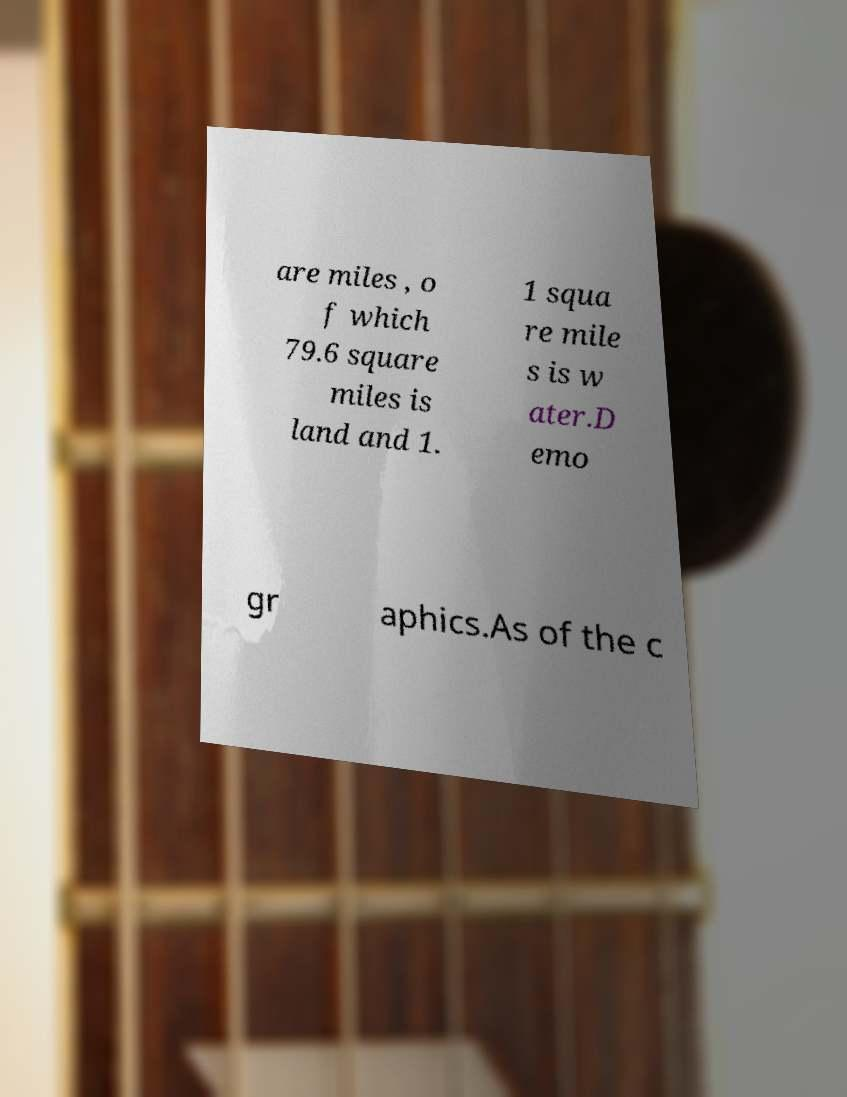I need the written content from this picture converted into text. Can you do that? are miles , o f which 79.6 square miles is land and 1. 1 squa re mile s is w ater.D emo gr aphics.As of the c 